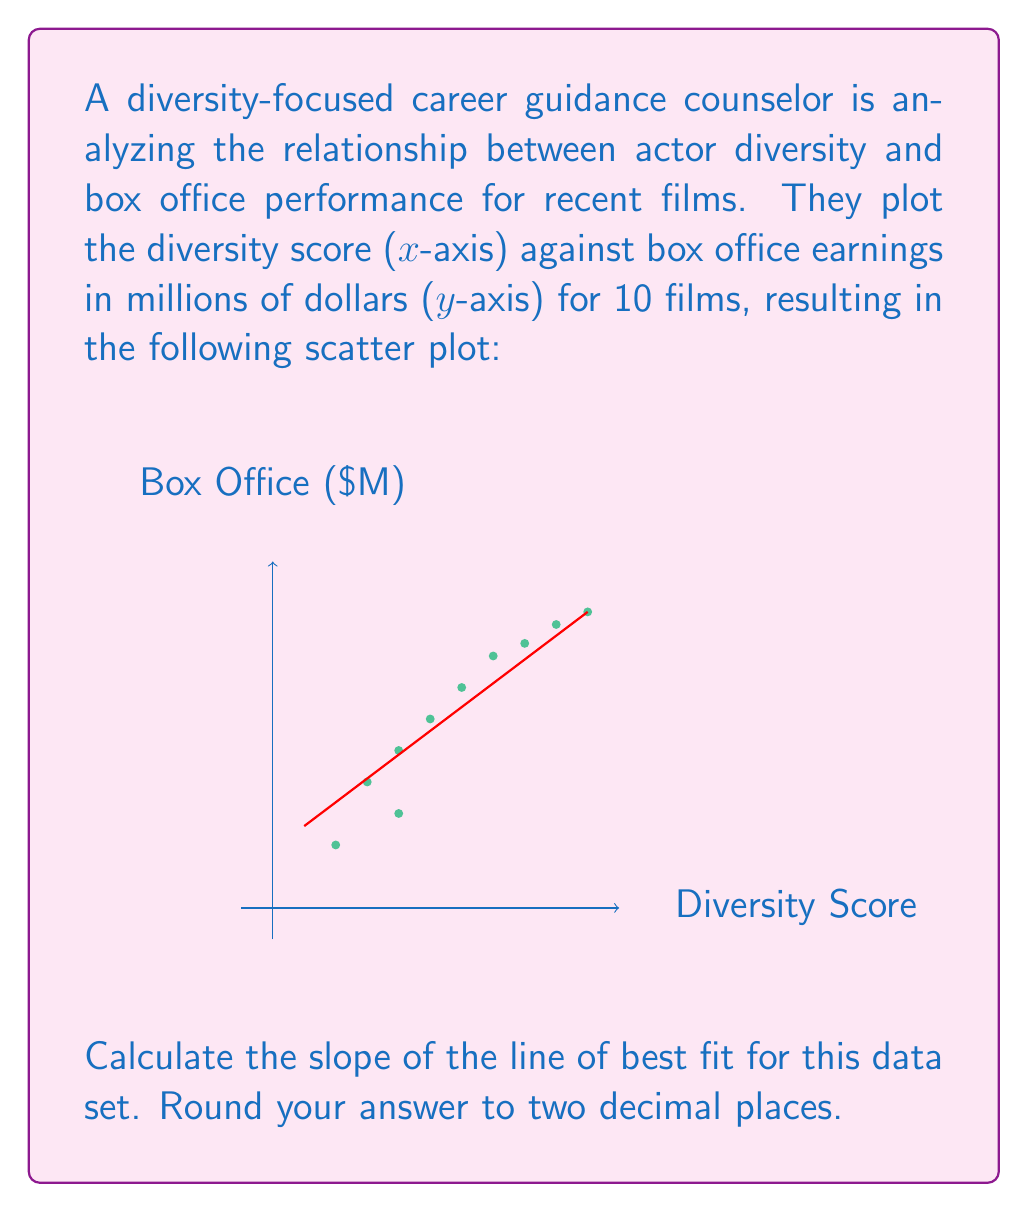Give your solution to this math problem. To calculate the slope of the line of best fit, we'll use the point-slope formula:

$$ m = \frac{y_2 - y_1}{x_2 - x_1} $$

Where $(x_1, y_1)$ and $(x_2, y_2)$ are two points on the line.

Step 1: Identify two points on the line of best fit.
From the graph, we can see that the line passes through approximately:
$(x_1, y_1) = (0.5, 1.3)$ and $(x_2, y_2) = (5, 4.7)$

Step 2: Substitute these values into the slope formula:

$$ m = \frac{4.7 - 1.3}{5 - 0.5} = \frac{3.4}{4.5} $$

Step 3: Calculate the result:

$$ m = 0.7555... $$

Step 4: Round to two decimal places:

$$ m \approx 0.76 $$

This slope indicates that for every 1-point increase in diversity score, there is an average increase of $0.76 million in box office earnings.
Answer: $0.76$ 